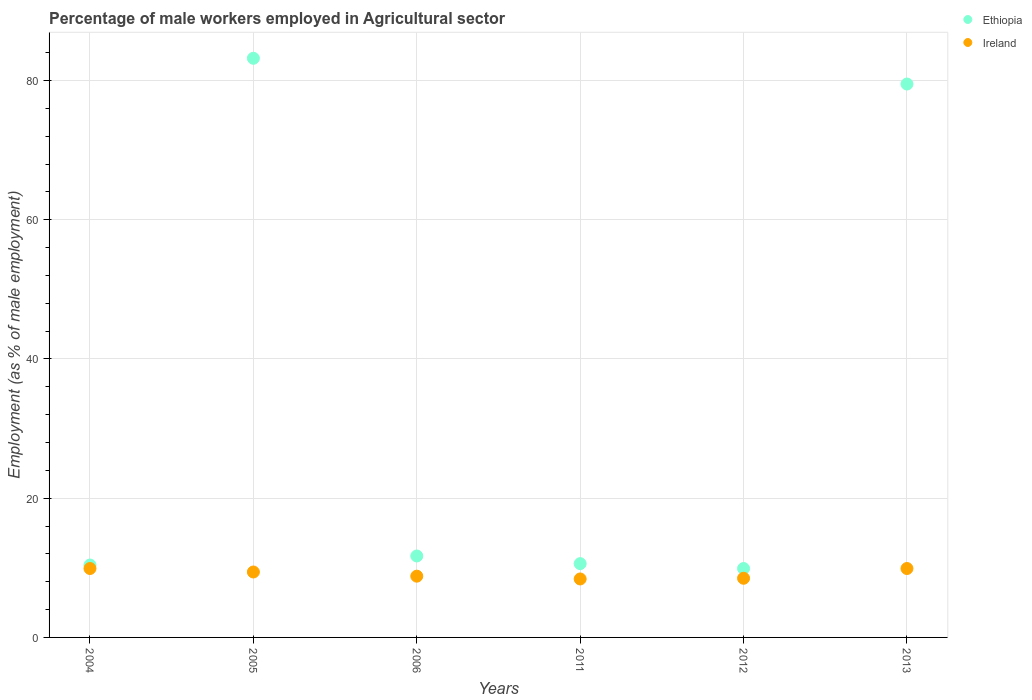Is the number of dotlines equal to the number of legend labels?
Offer a very short reply. Yes. What is the percentage of male workers employed in Agricultural sector in Ireland in 2011?
Your answer should be very brief. 8.4. Across all years, what is the maximum percentage of male workers employed in Agricultural sector in Ireland?
Keep it short and to the point. 9.9. Across all years, what is the minimum percentage of male workers employed in Agricultural sector in Ethiopia?
Provide a short and direct response. 9.9. In which year was the percentage of male workers employed in Agricultural sector in Ethiopia maximum?
Ensure brevity in your answer.  2005. In which year was the percentage of male workers employed in Agricultural sector in Ireland minimum?
Give a very brief answer. 2011. What is the total percentage of male workers employed in Agricultural sector in Ireland in the graph?
Your answer should be very brief. 54.9. What is the difference between the percentage of male workers employed in Agricultural sector in Ireland in 2004 and that in 2012?
Your answer should be compact. 1.4. What is the difference between the percentage of male workers employed in Agricultural sector in Ireland in 2011 and the percentage of male workers employed in Agricultural sector in Ethiopia in 2005?
Your answer should be compact. -74.8. What is the average percentage of male workers employed in Agricultural sector in Ethiopia per year?
Make the answer very short. 34.22. In the year 2004, what is the difference between the percentage of male workers employed in Agricultural sector in Ethiopia and percentage of male workers employed in Agricultural sector in Ireland?
Ensure brevity in your answer.  0.5. In how many years, is the percentage of male workers employed in Agricultural sector in Ethiopia greater than 68 %?
Your answer should be very brief. 2. What is the ratio of the percentage of male workers employed in Agricultural sector in Ethiopia in 2006 to that in 2011?
Offer a very short reply. 1.1. Is the percentage of male workers employed in Agricultural sector in Ethiopia in 2006 less than that in 2013?
Your response must be concise. Yes. What is the difference between the highest and the second highest percentage of male workers employed in Agricultural sector in Ireland?
Provide a succinct answer. 0. What is the difference between the highest and the lowest percentage of male workers employed in Agricultural sector in Ireland?
Ensure brevity in your answer.  1.5. In how many years, is the percentage of male workers employed in Agricultural sector in Ireland greater than the average percentage of male workers employed in Agricultural sector in Ireland taken over all years?
Provide a short and direct response. 3. Does the percentage of male workers employed in Agricultural sector in Ireland monotonically increase over the years?
Offer a very short reply. No. How many dotlines are there?
Ensure brevity in your answer.  2. Does the graph contain any zero values?
Offer a terse response. No. Does the graph contain grids?
Offer a very short reply. Yes. Where does the legend appear in the graph?
Offer a very short reply. Top right. How are the legend labels stacked?
Your answer should be very brief. Vertical. What is the title of the graph?
Provide a succinct answer. Percentage of male workers employed in Agricultural sector. What is the label or title of the X-axis?
Provide a succinct answer. Years. What is the label or title of the Y-axis?
Give a very brief answer. Employment (as % of male employment). What is the Employment (as % of male employment) in Ethiopia in 2004?
Offer a terse response. 10.4. What is the Employment (as % of male employment) in Ireland in 2004?
Keep it short and to the point. 9.9. What is the Employment (as % of male employment) in Ethiopia in 2005?
Your response must be concise. 83.2. What is the Employment (as % of male employment) in Ireland in 2005?
Keep it short and to the point. 9.4. What is the Employment (as % of male employment) of Ethiopia in 2006?
Provide a succinct answer. 11.7. What is the Employment (as % of male employment) of Ireland in 2006?
Provide a succinct answer. 8.8. What is the Employment (as % of male employment) in Ethiopia in 2011?
Give a very brief answer. 10.6. What is the Employment (as % of male employment) in Ireland in 2011?
Keep it short and to the point. 8.4. What is the Employment (as % of male employment) in Ethiopia in 2012?
Ensure brevity in your answer.  9.9. What is the Employment (as % of male employment) in Ireland in 2012?
Provide a short and direct response. 8.5. What is the Employment (as % of male employment) in Ethiopia in 2013?
Ensure brevity in your answer.  79.5. What is the Employment (as % of male employment) of Ireland in 2013?
Provide a succinct answer. 9.9. Across all years, what is the maximum Employment (as % of male employment) of Ethiopia?
Provide a succinct answer. 83.2. Across all years, what is the maximum Employment (as % of male employment) of Ireland?
Keep it short and to the point. 9.9. Across all years, what is the minimum Employment (as % of male employment) in Ethiopia?
Provide a succinct answer. 9.9. Across all years, what is the minimum Employment (as % of male employment) in Ireland?
Give a very brief answer. 8.4. What is the total Employment (as % of male employment) in Ethiopia in the graph?
Your response must be concise. 205.3. What is the total Employment (as % of male employment) of Ireland in the graph?
Offer a terse response. 54.9. What is the difference between the Employment (as % of male employment) in Ethiopia in 2004 and that in 2005?
Make the answer very short. -72.8. What is the difference between the Employment (as % of male employment) in Ethiopia in 2004 and that in 2011?
Your answer should be very brief. -0.2. What is the difference between the Employment (as % of male employment) of Ireland in 2004 and that in 2011?
Make the answer very short. 1.5. What is the difference between the Employment (as % of male employment) in Ethiopia in 2004 and that in 2012?
Make the answer very short. 0.5. What is the difference between the Employment (as % of male employment) in Ireland in 2004 and that in 2012?
Provide a succinct answer. 1.4. What is the difference between the Employment (as % of male employment) of Ethiopia in 2004 and that in 2013?
Keep it short and to the point. -69.1. What is the difference between the Employment (as % of male employment) of Ethiopia in 2005 and that in 2006?
Make the answer very short. 71.5. What is the difference between the Employment (as % of male employment) of Ethiopia in 2005 and that in 2011?
Your answer should be compact. 72.6. What is the difference between the Employment (as % of male employment) of Ethiopia in 2005 and that in 2012?
Your answer should be very brief. 73.3. What is the difference between the Employment (as % of male employment) in Ethiopia in 2005 and that in 2013?
Provide a succinct answer. 3.7. What is the difference between the Employment (as % of male employment) of Ireland in 2006 and that in 2011?
Ensure brevity in your answer.  0.4. What is the difference between the Employment (as % of male employment) in Ethiopia in 2006 and that in 2013?
Offer a terse response. -67.8. What is the difference between the Employment (as % of male employment) of Ireland in 2006 and that in 2013?
Ensure brevity in your answer.  -1.1. What is the difference between the Employment (as % of male employment) in Ethiopia in 2011 and that in 2012?
Make the answer very short. 0.7. What is the difference between the Employment (as % of male employment) in Ethiopia in 2011 and that in 2013?
Keep it short and to the point. -68.9. What is the difference between the Employment (as % of male employment) in Ireland in 2011 and that in 2013?
Offer a terse response. -1.5. What is the difference between the Employment (as % of male employment) of Ethiopia in 2012 and that in 2013?
Your response must be concise. -69.6. What is the difference between the Employment (as % of male employment) in Ethiopia in 2004 and the Employment (as % of male employment) in Ireland in 2005?
Offer a terse response. 1. What is the difference between the Employment (as % of male employment) of Ethiopia in 2004 and the Employment (as % of male employment) of Ireland in 2011?
Your answer should be compact. 2. What is the difference between the Employment (as % of male employment) in Ethiopia in 2005 and the Employment (as % of male employment) in Ireland in 2006?
Ensure brevity in your answer.  74.4. What is the difference between the Employment (as % of male employment) of Ethiopia in 2005 and the Employment (as % of male employment) of Ireland in 2011?
Your answer should be very brief. 74.8. What is the difference between the Employment (as % of male employment) in Ethiopia in 2005 and the Employment (as % of male employment) in Ireland in 2012?
Offer a very short reply. 74.7. What is the difference between the Employment (as % of male employment) in Ethiopia in 2005 and the Employment (as % of male employment) in Ireland in 2013?
Make the answer very short. 73.3. What is the difference between the Employment (as % of male employment) of Ethiopia in 2006 and the Employment (as % of male employment) of Ireland in 2011?
Offer a very short reply. 3.3. What is the difference between the Employment (as % of male employment) in Ethiopia in 2006 and the Employment (as % of male employment) in Ireland in 2013?
Offer a terse response. 1.8. What is the average Employment (as % of male employment) in Ethiopia per year?
Ensure brevity in your answer.  34.22. What is the average Employment (as % of male employment) in Ireland per year?
Keep it short and to the point. 9.15. In the year 2005, what is the difference between the Employment (as % of male employment) of Ethiopia and Employment (as % of male employment) of Ireland?
Give a very brief answer. 73.8. In the year 2013, what is the difference between the Employment (as % of male employment) of Ethiopia and Employment (as % of male employment) of Ireland?
Give a very brief answer. 69.6. What is the ratio of the Employment (as % of male employment) in Ireland in 2004 to that in 2005?
Give a very brief answer. 1.05. What is the ratio of the Employment (as % of male employment) in Ethiopia in 2004 to that in 2011?
Give a very brief answer. 0.98. What is the ratio of the Employment (as % of male employment) in Ireland in 2004 to that in 2011?
Ensure brevity in your answer.  1.18. What is the ratio of the Employment (as % of male employment) of Ethiopia in 2004 to that in 2012?
Offer a very short reply. 1.05. What is the ratio of the Employment (as % of male employment) of Ireland in 2004 to that in 2012?
Give a very brief answer. 1.16. What is the ratio of the Employment (as % of male employment) in Ethiopia in 2004 to that in 2013?
Provide a succinct answer. 0.13. What is the ratio of the Employment (as % of male employment) of Ireland in 2004 to that in 2013?
Provide a short and direct response. 1. What is the ratio of the Employment (as % of male employment) in Ethiopia in 2005 to that in 2006?
Your response must be concise. 7.11. What is the ratio of the Employment (as % of male employment) of Ireland in 2005 to that in 2006?
Your answer should be very brief. 1.07. What is the ratio of the Employment (as % of male employment) of Ethiopia in 2005 to that in 2011?
Provide a short and direct response. 7.85. What is the ratio of the Employment (as % of male employment) of Ireland in 2005 to that in 2011?
Offer a very short reply. 1.12. What is the ratio of the Employment (as % of male employment) of Ethiopia in 2005 to that in 2012?
Your answer should be very brief. 8.4. What is the ratio of the Employment (as % of male employment) of Ireland in 2005 to that in 2012?
Provide a short and direct response. 1.11. What is the ratio of the Employment (as % of male employment) of Ethiopia in 2005 to that in 2013?
Offer a terse response. 1.05. What is the ratio of the Employment (as % of male employment) of Ireland in 2005 to that in 2013?
Offer a terse response. 0.95. What is the ratio of the Employment (as % of male employment) in Ethiopia in 2006 to that in 2011?
Provide a short and direct response. 1.1. What is the ratio of the Employment (as % of male employment) in Ireland in 2006 to that in 2011?
Keep it short and to the point. 1.05. What is the ratio of the Employment (as % of male employment) of Ethiopia in 2006 to that in 2012?
Offer a terse response. 1.18. What is the ratio of the Employment (as % of male employment) in Ireland in 2006 to that in 2012?
Give a very brief answer. 1.04. What is the ratio of the Employment (as % of male employment) in Ethiopia in 2006 to that in 2013?
Your answer should be compact. 0.15. What is the ratio of the Employment (as % of male employment) of Ireland in 2006 to that in 2013?
Offer a terse response. 0.89. What is the ratio of the Employment (as % of male employment) in Ethiopia in 2011 to that in 2012?
Your response must be concise. 1.07. What is the ratio of the Employment (as % of male employment) of Ethiopia in 2011 to that in 2013?
Provide a succinct answer. 0.13. What is the ratio of the Employment (as % of male employment) in Ireland in 2011 to that in 2013?
Offer a terse response. 0.85. What is the ratio of the Employment (as % of male employment) in Ethiopia in 2012 to that in 2013?
Your answer should be very brief. 0.12. What is the ratio of the Employment (as % of male employment) in Ireland in 2012 to that in 2013?
Ensure brevity in your answer.  0.86. What is the difference between the highest and the second highest Employment (as % of male employment) of Ireland?
Keep it short and to the point. 0. What is the difference between the highest and the lowest Employment (as % of male employment) of Ethiopia?
Your answer should be very brief. 73.3. 